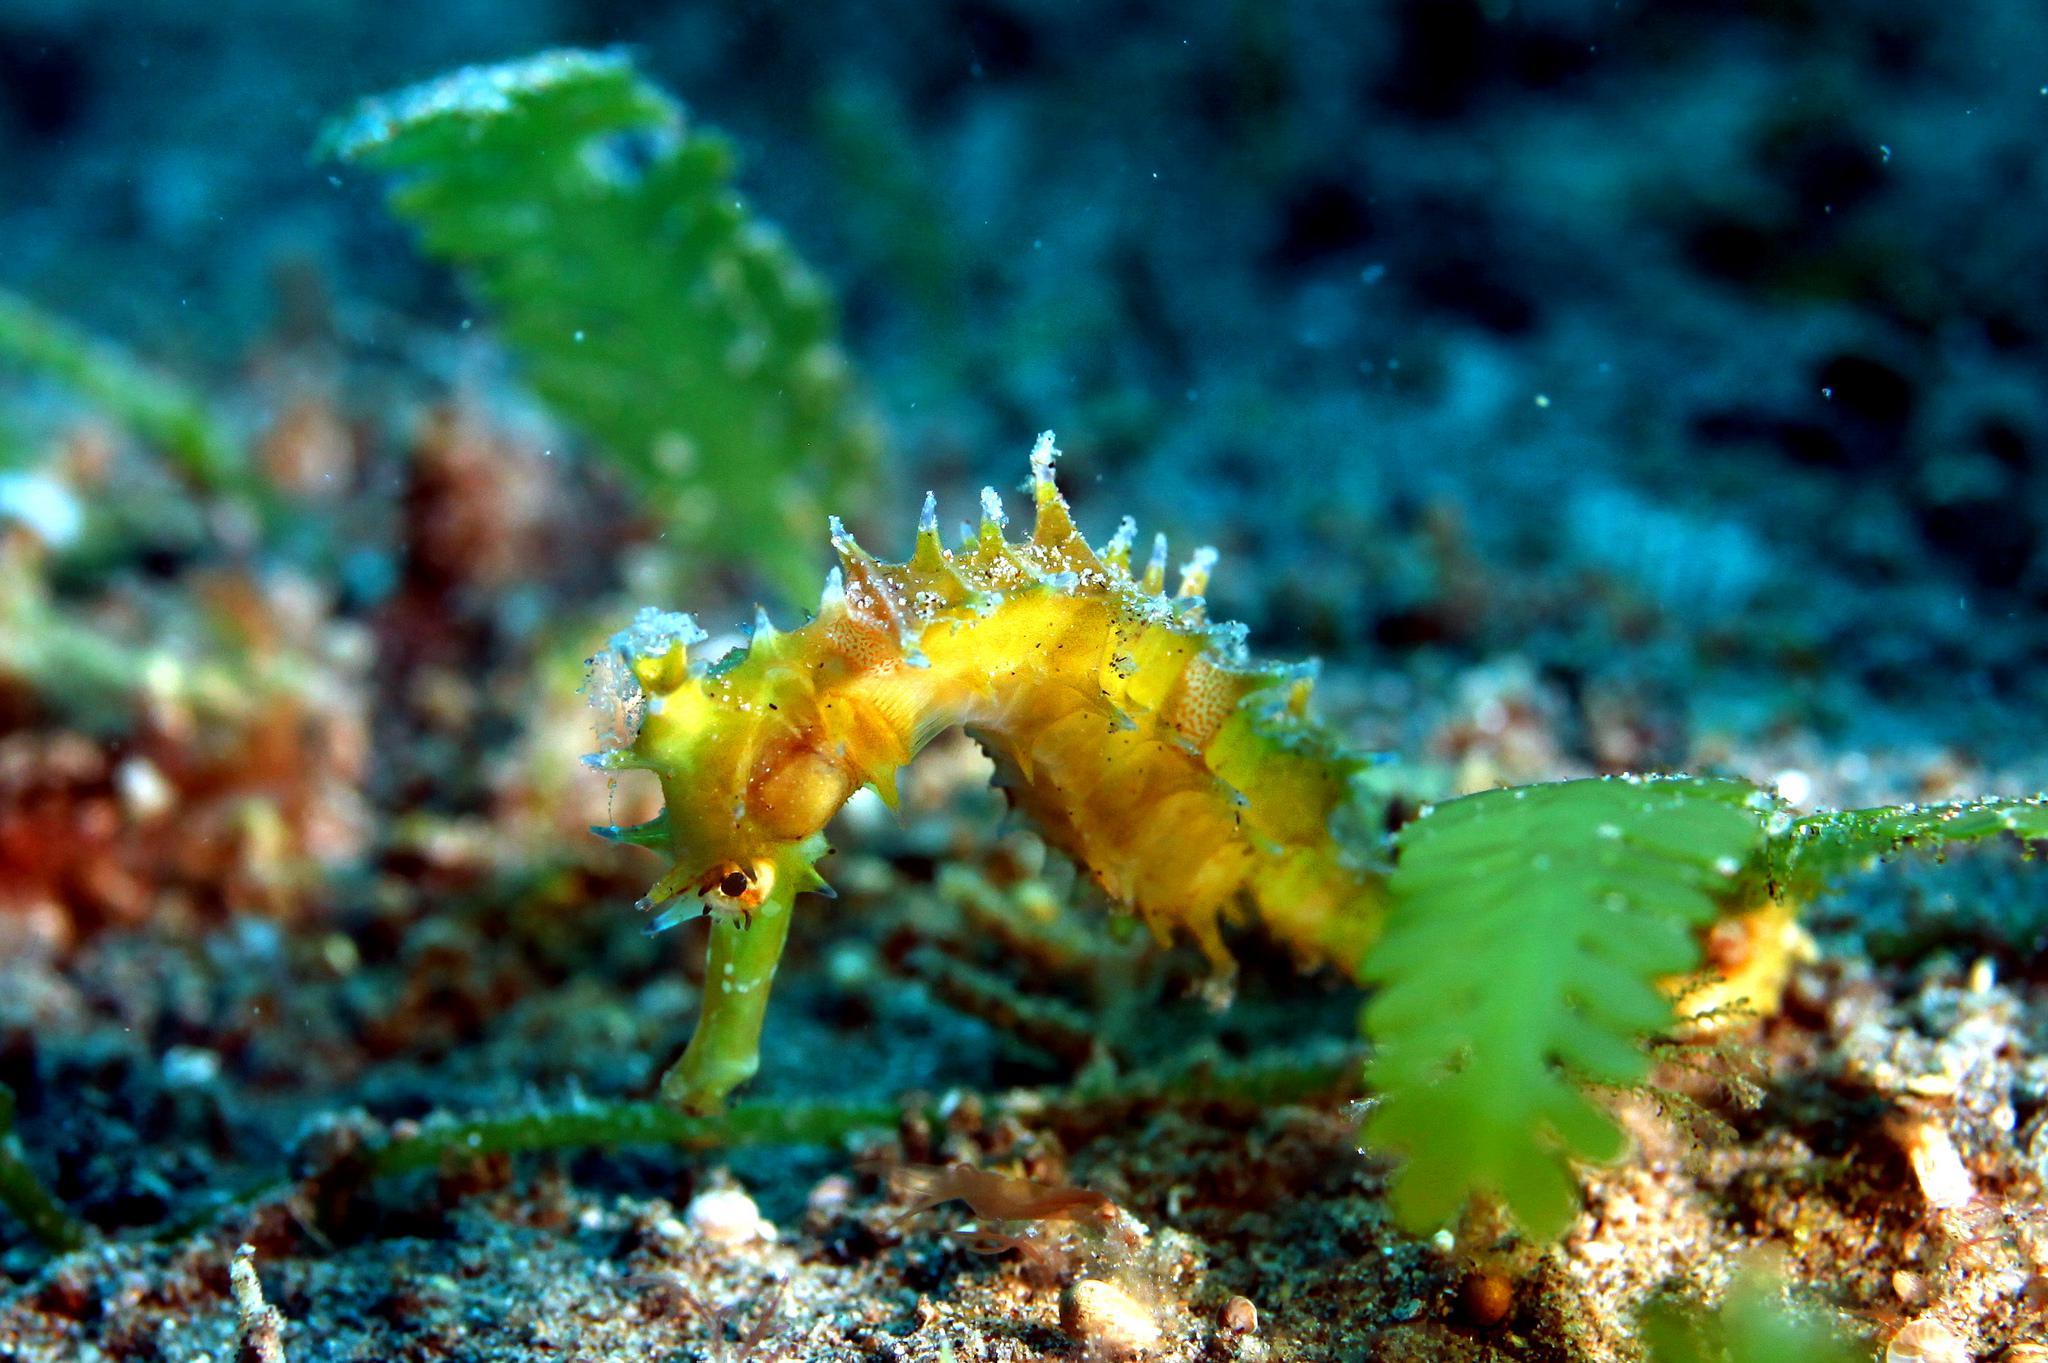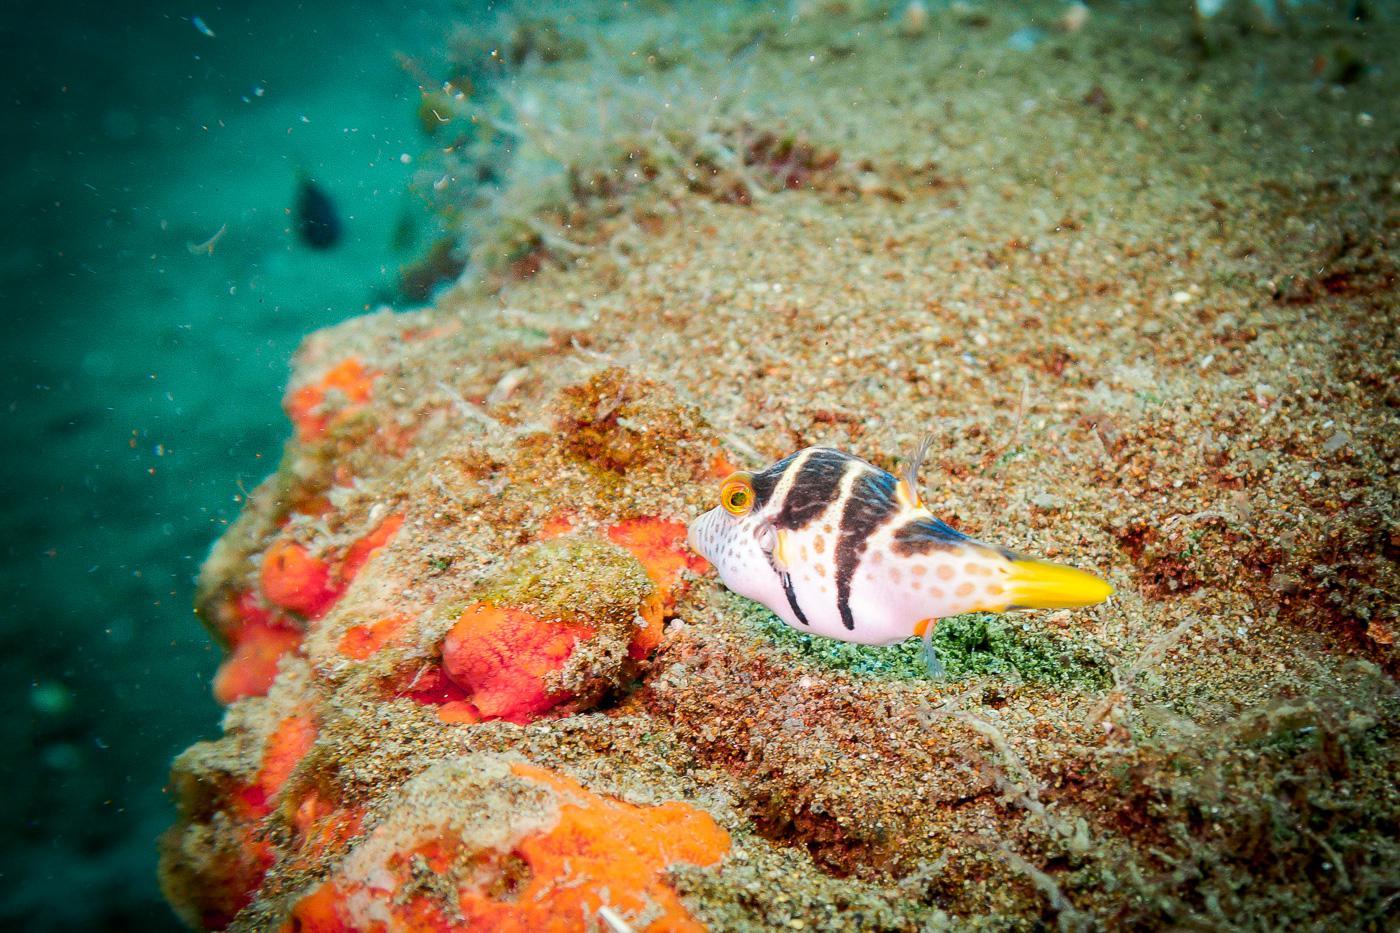The first image is the image on the left, the second image is the image on the right. Assess this claim about the two images: "A white and black striped fish is swimming in the water in the image on the right.". Correct or not? Answer yes or no. Yes. The first image is the image on the left, the second image is the image on the right. For the images shown, is this caption "The right image contains some creature with black and white stripes and with two antenna-type horns and something flower-like sprouting from its back." true? Answer yes or no. No. 